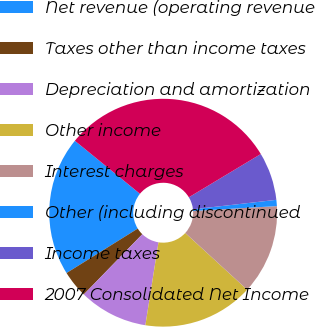Convert chart to OTSL. <chart><loc_0><loc_0><loc_500><loc_500><pie_chart><fcel>Net revenue (operating revenue<fcel>Taxes other than income taxes<fcel>Depreciation and amortization<fcel>Other income<fcel>Interest charges<fcel>Other (including discontinued<fcel>Income taxes<fcel>2007 Consolidated Net Income<nl><fcel>19.76%<fcel>3.85%<fcel>9.77%<fcel>15.69%<fcel>12.73%<fcel>0.88%<fcel>6.81%<fcel>30.5%<nl></chart> 